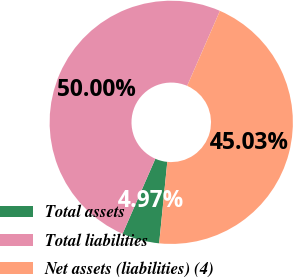<chart> <loc_0><loc_0><loc_500><loc_500><pie_chart><fcel>Total assets<fcel>Total liabilities<fcel>Net assets (liabilities) (4)<nl><fcel>4.97%<fcel>50.0%<fcel>45.03%<nl></chart> 